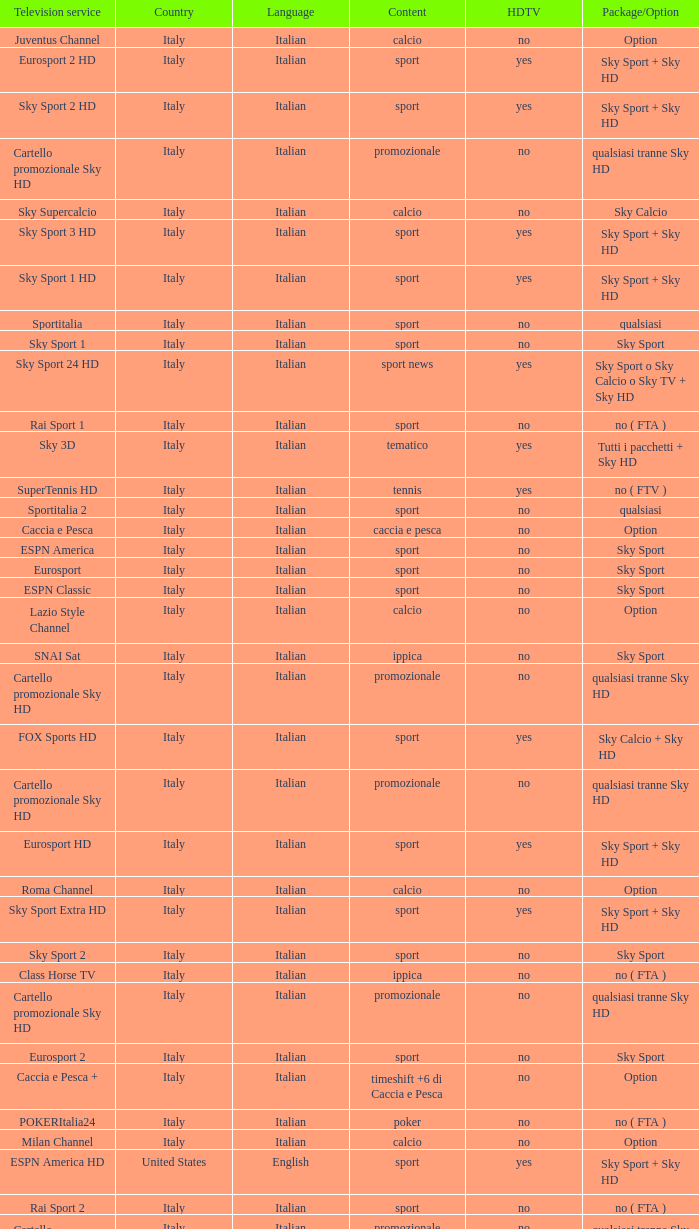What is Package/Option, when Content is Tennis? No ( ftv ). 